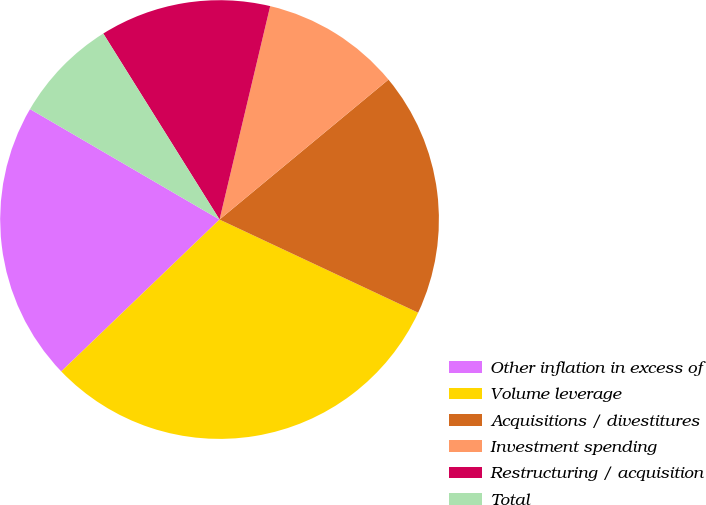Convert chart to OTSL. <chart><loc_0><loc_0><loc_500><loc_500><pie_chart><fcel>Other inflation in excess of<fcel>Volume leverage<fcel>Acquisitions / divestitures<fcel>Investment spending<fcel>Restructuring / acquisition<fcel>Total<nl><fcel>20.57%<fcel>30.85%<fcel>17.99%<fcel>10.28%<fcel>12.6%<fcel>7.71%<nl></chart> 